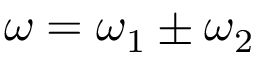Convert formula to latex. <formula><loc_0><loc_0><loc_500><loc_500>\omega = \omega _ { 1 } \pm \omega _ { 2 }</formula> 